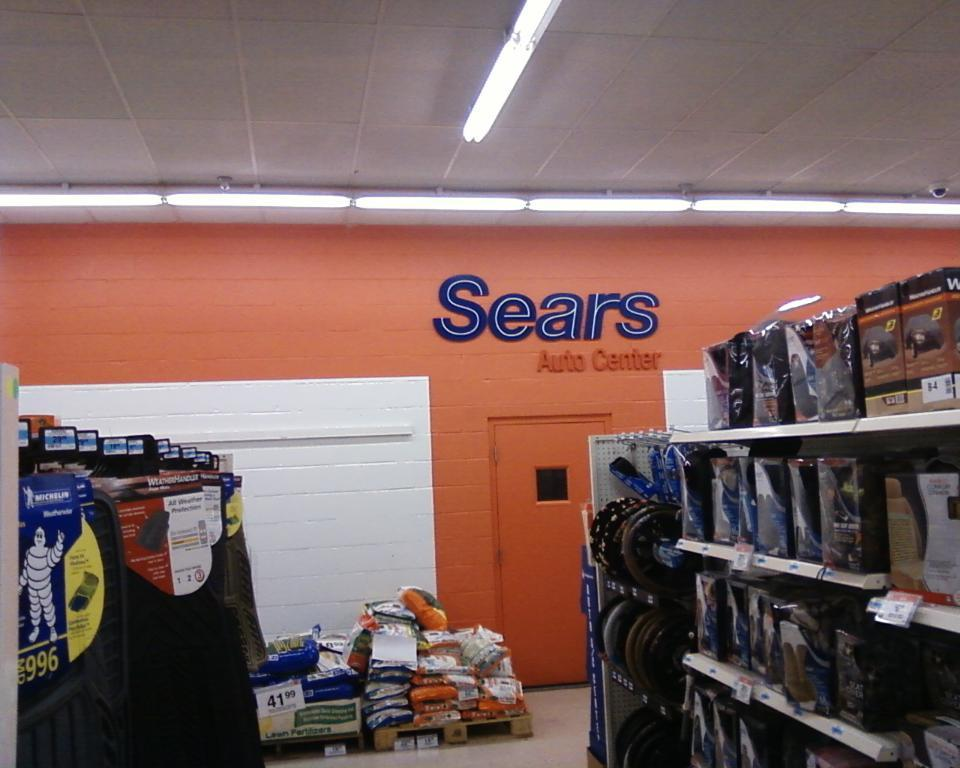<image>
Render a clear and concise summary of the photo. an interior of a Sears Auto Center showing the shelves of goods 